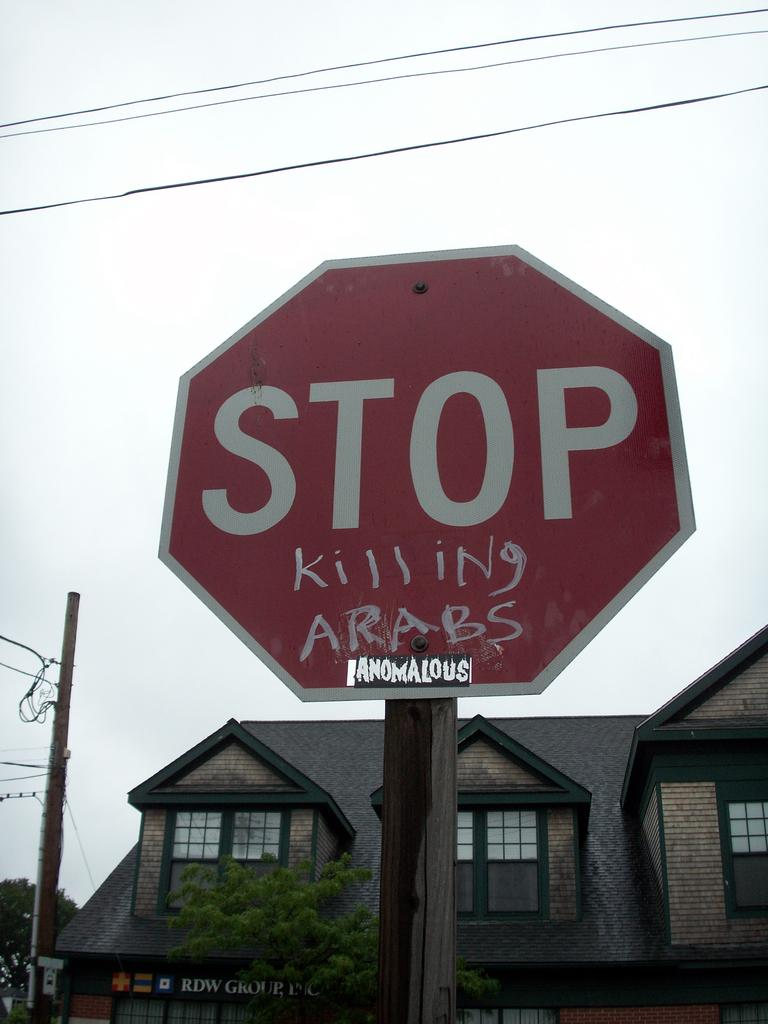<image>
Present a compact description of the photo's key features. The Stop signed had graffiti on it saying, "killing Arabs." 